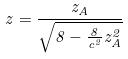Convert formula to latex. <formula><loc_0><loc_0><loc_500><loc_500>z = \frac { z _ { A } } { \sqrt { 8 - \frac { 8 } { c ^ { 2 } } z _ { A } ^ { 2 } } }</formula> 